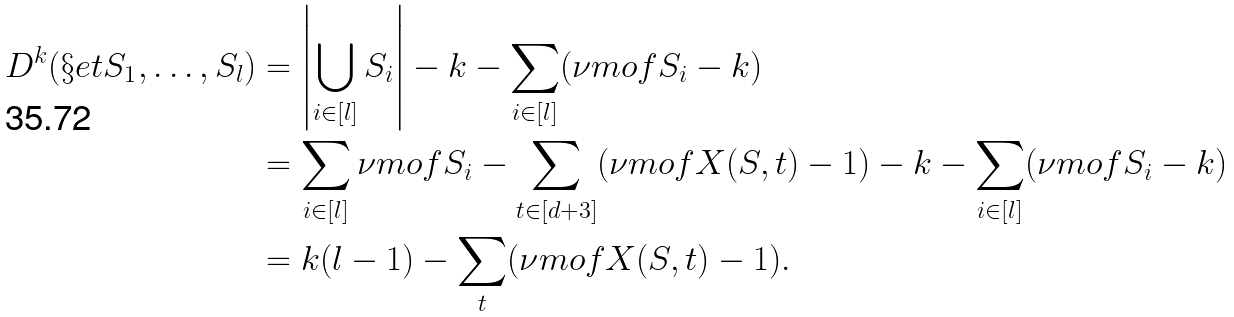Convert formula to latex. <formula><loc_0><loc_0><loc_500><loc_500>D ^ { k } ( \S e t { S _ { 1 } , \dots , S _ { l } } ) & = \left | \bigcup _ { i \in [ l ] } S _ { i } \right | - k - \sum _ { i \in [ l ] } ( \nu m o f { S _ { i } } - k ) \\ & = \sum _ { i \in [ l ] } \nu m o f { S _ { i } } - \sum _ { t \in [ d + 3 ] } ( \nu m o f { X ( S , t ) } - 1 ) - k - \sum _ { i \in [ l ] } ( \nu m o f { S _ { i } } - k ) \\ & = k ( l - 1 ) - \sum _ { t } ( \nu m o f { X ( S , t ) } - 1 ) .</formula> 